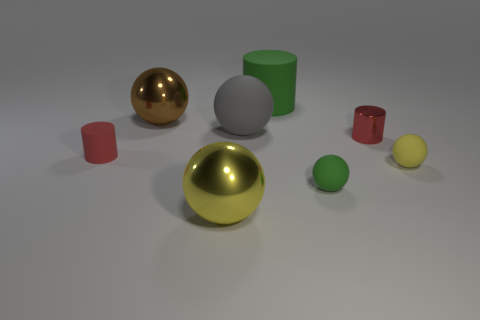What is the color of the small metal cylinder?
Offer a terse response. Red. Are there any red cylinders made of the same material as the large gray ball?
Keep it short and to the point. Yes. Is there a tiny ball that is on the left side of the large sphere that is in front of the yellow ball that is on the right side of the large green matte cylinder?
Your answer should be compact. No. Are there any brown metal objects behind the large green matte cylinder?
Offer a very short reply. No. Is there a tiny cylinder of the same color as the large matte sphere?
Provide a short and direct response. No. What number of small objects are either cyan blocks or yellow metal balls?
Offer a very short reply. 0. Do the red thing that is to the right of the large gray rubber sphere and the tiny green thing have the same material?
Give a very brief answer. No. There is a tiny red thing behind the tiny cylinder that is left of the big metal object that is in front of the small yellow thing; what is its shape?
Give a very brief answer. Cylinder. How many cyan things are either big rubber cylinders or cylinders?
Offer a terse response. 0. Are there an equal number of gray things that are right of the gray rubber thing and large gray matte balls to the left of the big brown metallic object?
Offer a very short reply. Yes. 